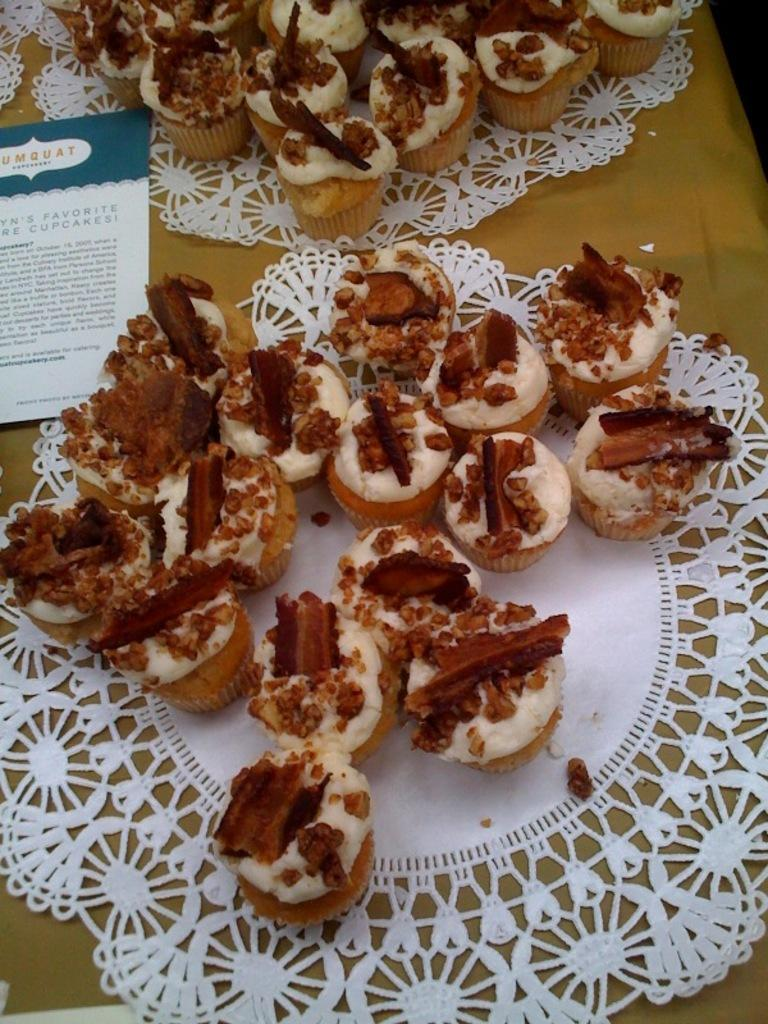How many plates are visible in the image? There are two plates in the image. What is on the plates? There are cupcakes on the plates. What else can be seen in the image besides the plates and cupcakes? There is a card in the image. Where are the plates, cupcakes, and card located? The objects are placed on a table. What type of police account can be seen in the image? There is no police account or any reference to police in the image. 